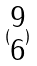<formula> <loc_0><loc_0><loc_500><loc_500>( \begin{matrix} 9 \\ 6 \end{matrix} )</formula> 